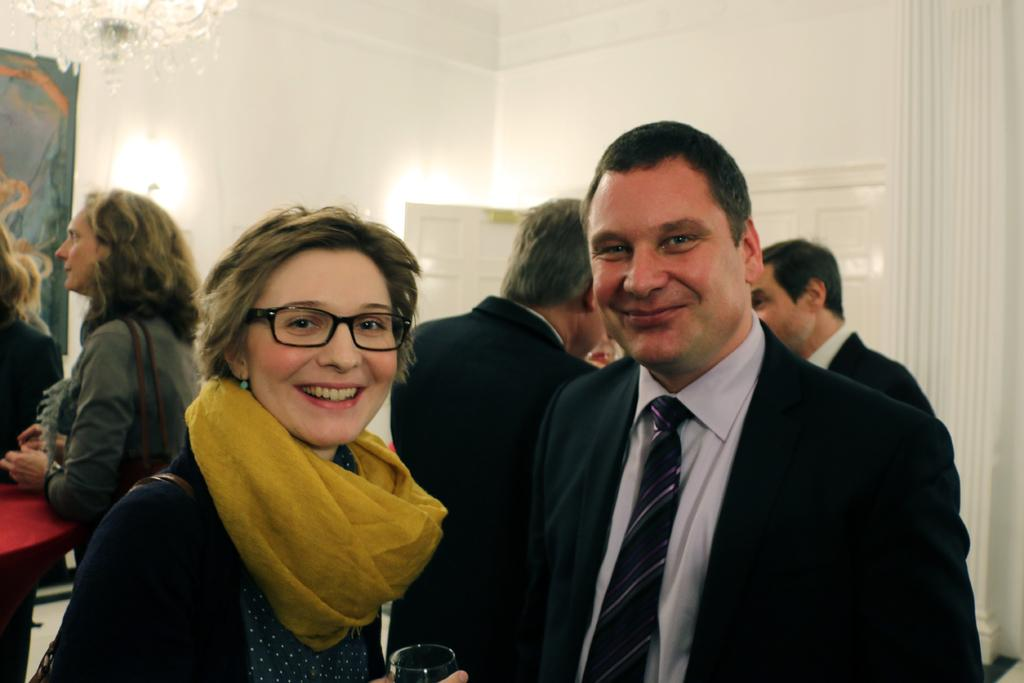How many people are in the image? There is a group of people in the image. What are the people doing in the image? The people are standing. What is behind the people in the image? There is a wall behind the people. What type of lighting fixture is in the image? There is a chandelier in the image. What color is the kite that is being flown by the people in the image? There is no kite present in the image; the people are standing and not flying any kites. 